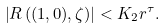<formula> <loc_0><loc_0><loc_500><loc_500>\left | R \left ( ( 1 , 0 ) , \zeta \right ) \right | < K _ { 2 } r ^ { \tau } .</formula> 